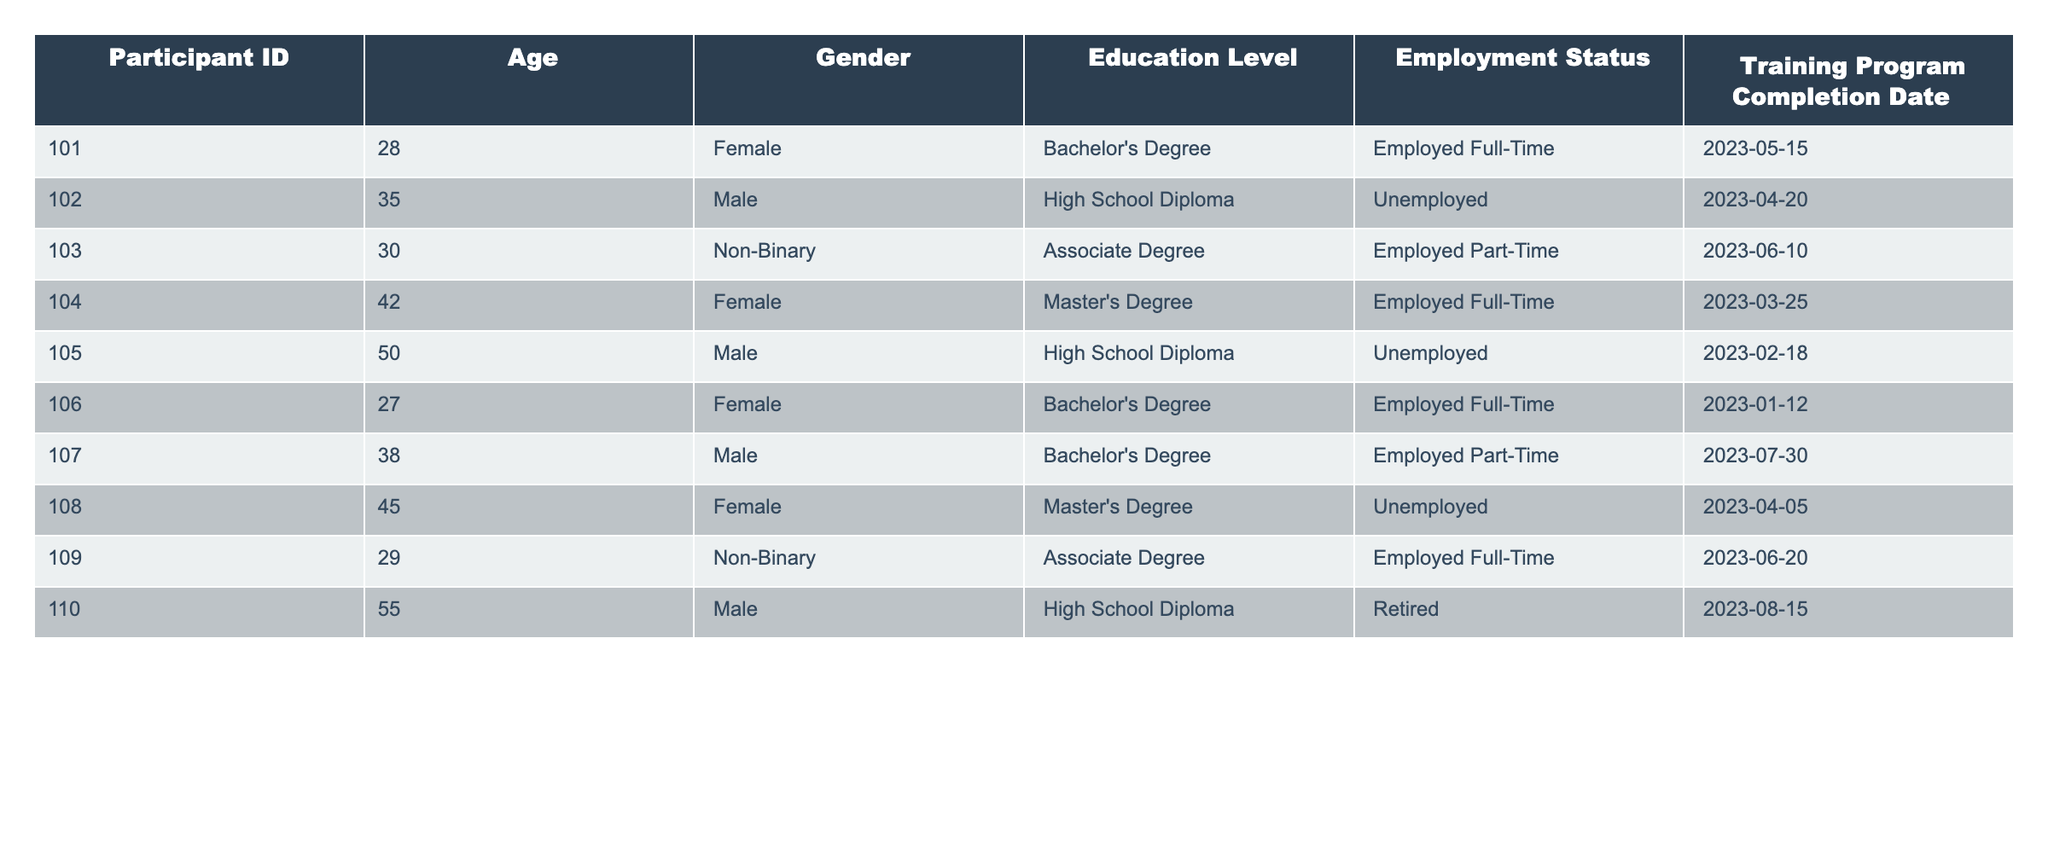What is the employment status of Participant ID 101? Participant ID 101 is listed as "Employed Full-Time" in the Employment Status column.
Answer: Employed Full-Time How many participants are unemployed? By counting the entries in the Employment Status column, there are three participants (IDs 102, 105, and 108) listed as unemployed.
Answer: 3 What is the average age of participants who are employed full-time? The ages of participants employed full-time are 28 (ID 101), 42 (ID 104), and 29 (ID 109). The average age is (28 + 42 + 29) / 3 = 99 / 3 = 33.
Answer: 33 Is there any participant with a Master's Degree who is unemployed? By examining the table, Participant ID 108 has a Master's Degree and is listed as unemployed. Therefore, the statement is true.
Answer: Yes How many males are employed part-time? Looking at the Employment Status for male participants, Participant ID 107 is the only male who is employed part-time.
Answer: 1 What is the total number of participants who completed the training program? All participants listed in the table have a Training Program Completion Date, indicating that they completed the program. There are 10 participants in total.
Answer: 10 How many participants have a high school diploma but are unemployed? By checking the Educational Level and Employment Status columns, Participant ID 102 and Participant ID 105 both have a high school diploma and are unemployed, resulting in a total of two participants.
Answer: 2 Which gender has the highest proportion of full-time employment? Observing the Employment Status, there are 5 full-time employees (3 females and 2 non-binary) out of 10 participants, while the rest are split among part-time and other statuses. Since there are 5 females, the proportion is higher for females.
Answer: Female What is the median age of participants who completed the training program? The ages listed are 28, 35, 30, 42, 50, 27, 38, 45, 29, and 55. When sorted (27, 28, 29, 30, 35, 38, 42, 45, 50, 55), the median is the average of the 5th and 6th entries: (35 + 38) / 2 = 36.5.
Answer: 36.5 How many participants are gender non-binary, and what is their employment status? There are two non-binary participants (IDs 103 and 109), with one employed part-time and the other employed full-time.
Answer: 2 (Employed Part-Time, Employed Full-Time) 